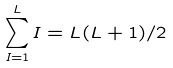<formula> <loc_0><loc_0><loc_500><loc_500>\sum _ { I = 1 } ^ { L } I = L ( L + 1 ) / 2</formula> 